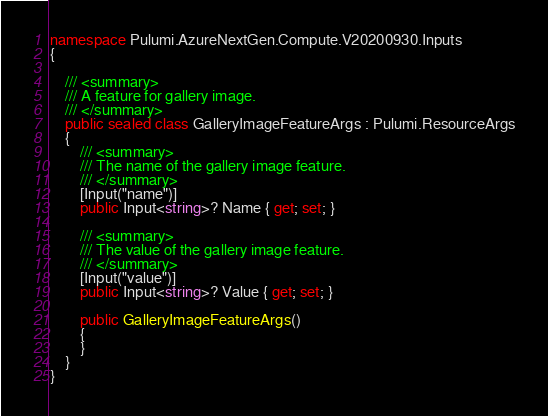<code> <loc_0><loc_0><loc_500><loc_500><_C#_>
namespace Pulumi.AzureNextGen.Compute.V20200930.Inputs
{

    /// <summary>
    /// A feature for gallery image.
    /// </summary>
    public sealed class GalleryImageFeatureArgs : Pulumi.ResourceArgs
    {
        /// <summary>
        /// The name of the gallery image feature.
        /// </summary>
        [Input("name")]
        public Input<string>? Name { get; set; }

        /// <summary>
        /// The value of the gallery image feature.
        /// </summary>
        [Input("value")]
        public Input<string>? Value { get; set; }

        public GalleryImageFeatureArgs()
        {
        }
    }
}
</code> 